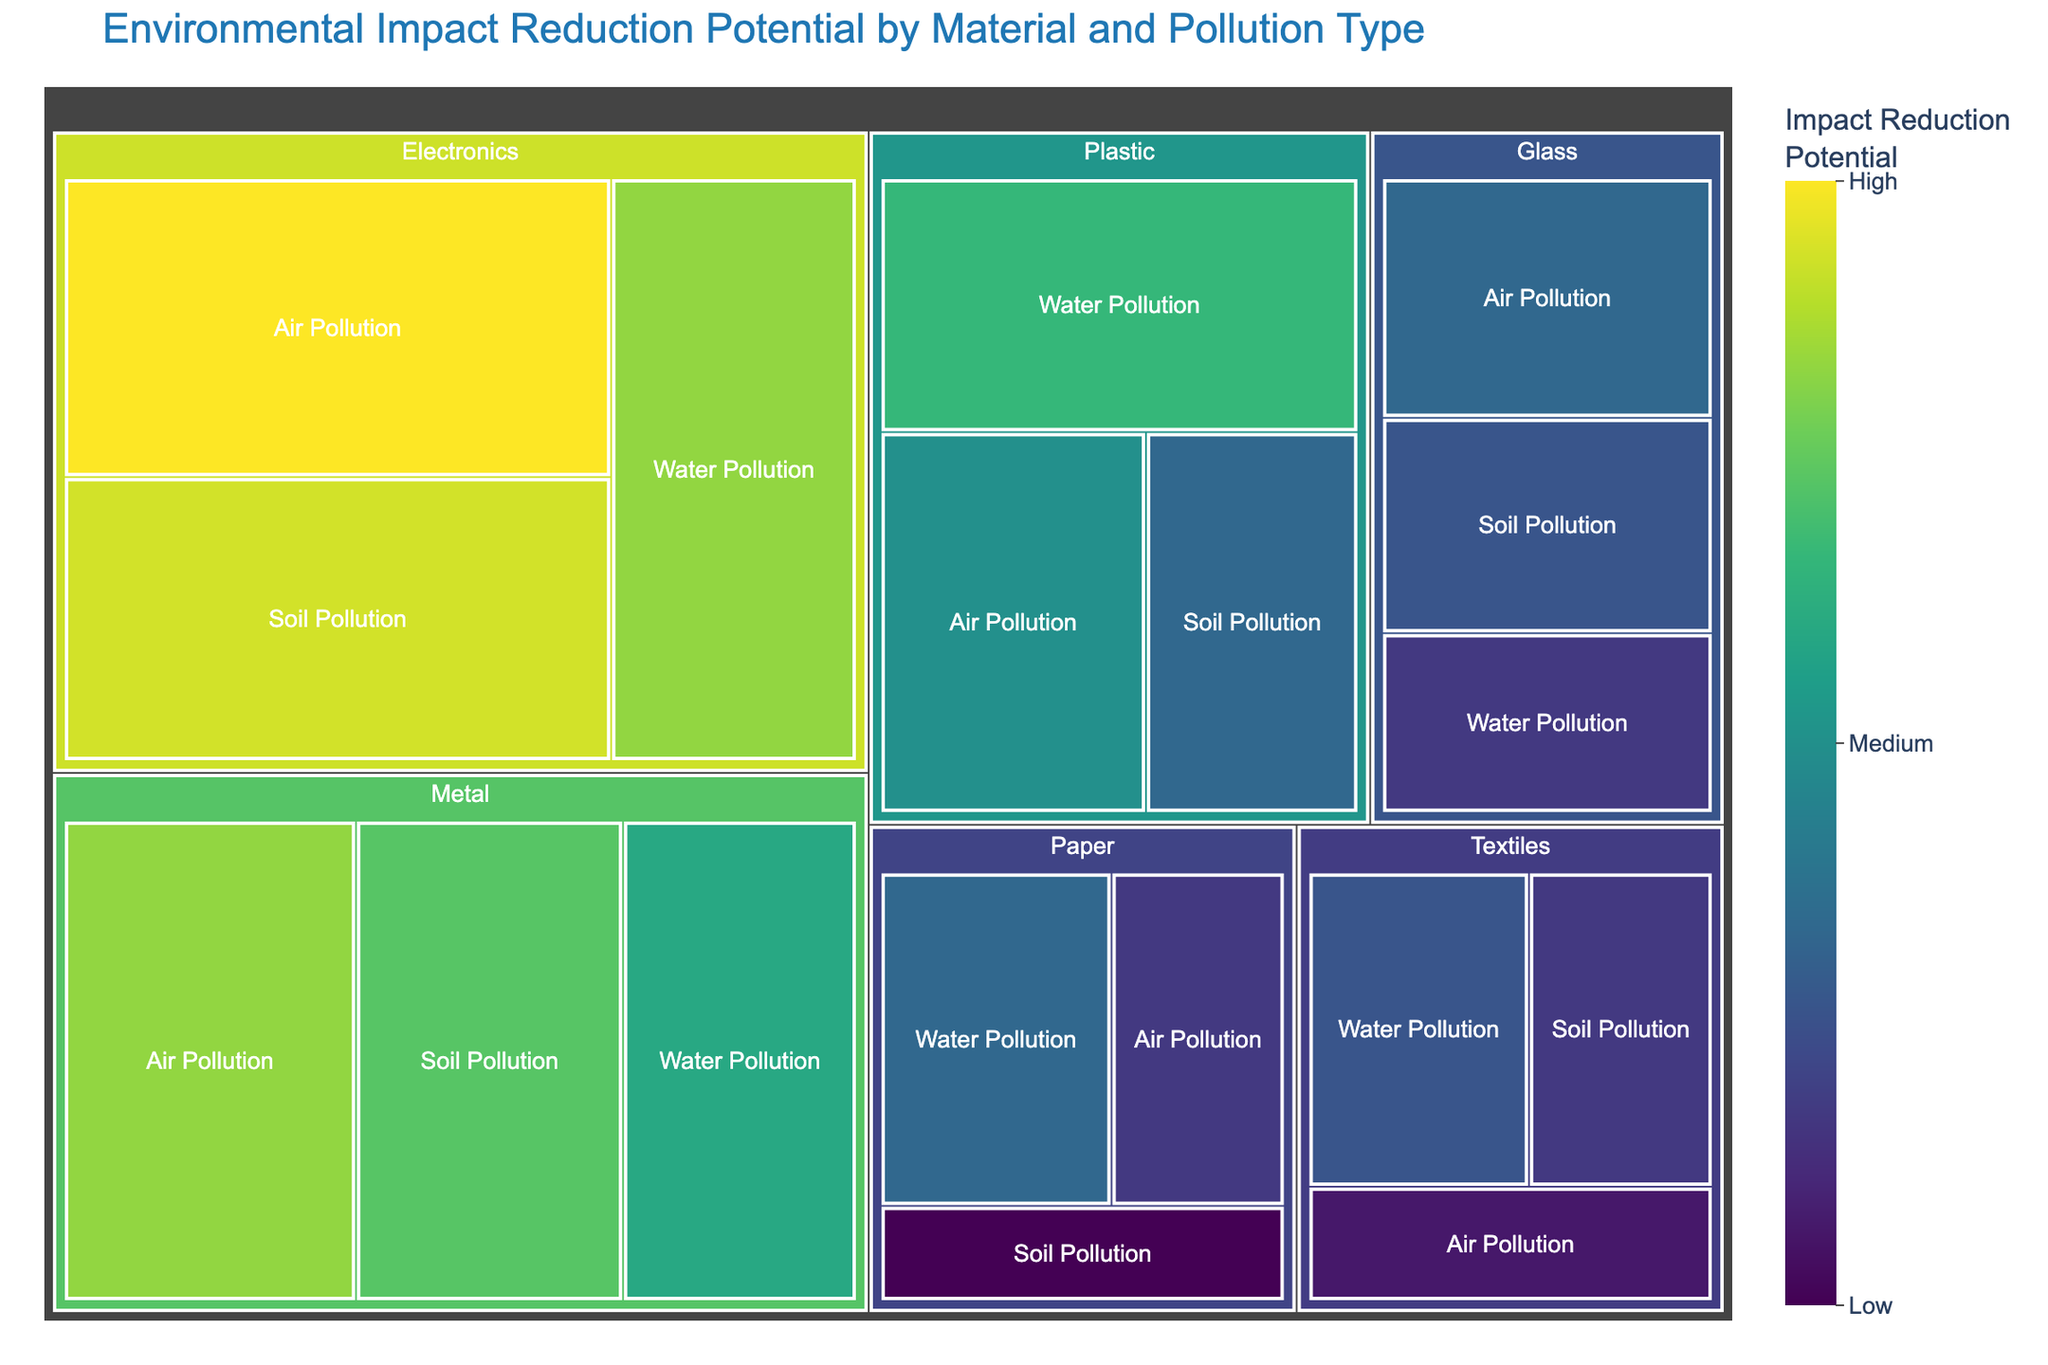What's the title of the Treemap? The title is prominently displayed at the top of the Treemap.
Answer: Environmental Impact Reduction Potential by Material and Pollution Type Which material has the highest impact reduction potential for air pollution? Look at the section under "Air Pollution" and identify the material with the largest value.
Answer: Electronics Which material contributes the least to water pollution impact reduction? Assess the values under the "Water Pollution" category and find the material with the smallest value.
Answer: Glass Which pollution type does metal have the highest impact reduction potential for? Examine the values under the "Metal" category and identify the highest impact reduction potential among the pollution types.
Answer: Air Pollution How does the impact reduction potential of textiles compare between water pollution and soil pollution? Compare the values of impact reduction potential for textiles between these two categories.
Answer: Higher for Water Pollution What's the total impact reduction potential for plastic across all pollution types? Sum the values of all pollution types under plastic: 25 (Air) + 30 (Water) + 20 (Soil).
Answer: 75 Rank the materials from highest to lowest impact reduction potential for soil pollution. Examine the values for soil pollution impact reduction for each material and sort them in descending order.
Answer: Electronics, Metal, Glass, Plastic, Textiles, Paper How much higher is the impact reduction potential of recycling electronics for air pollution compared to textiles for the same pollution type? Subtract the impact reduction potential of textiles from electronics for air pollution: 40 - 12.
Answer: 28 